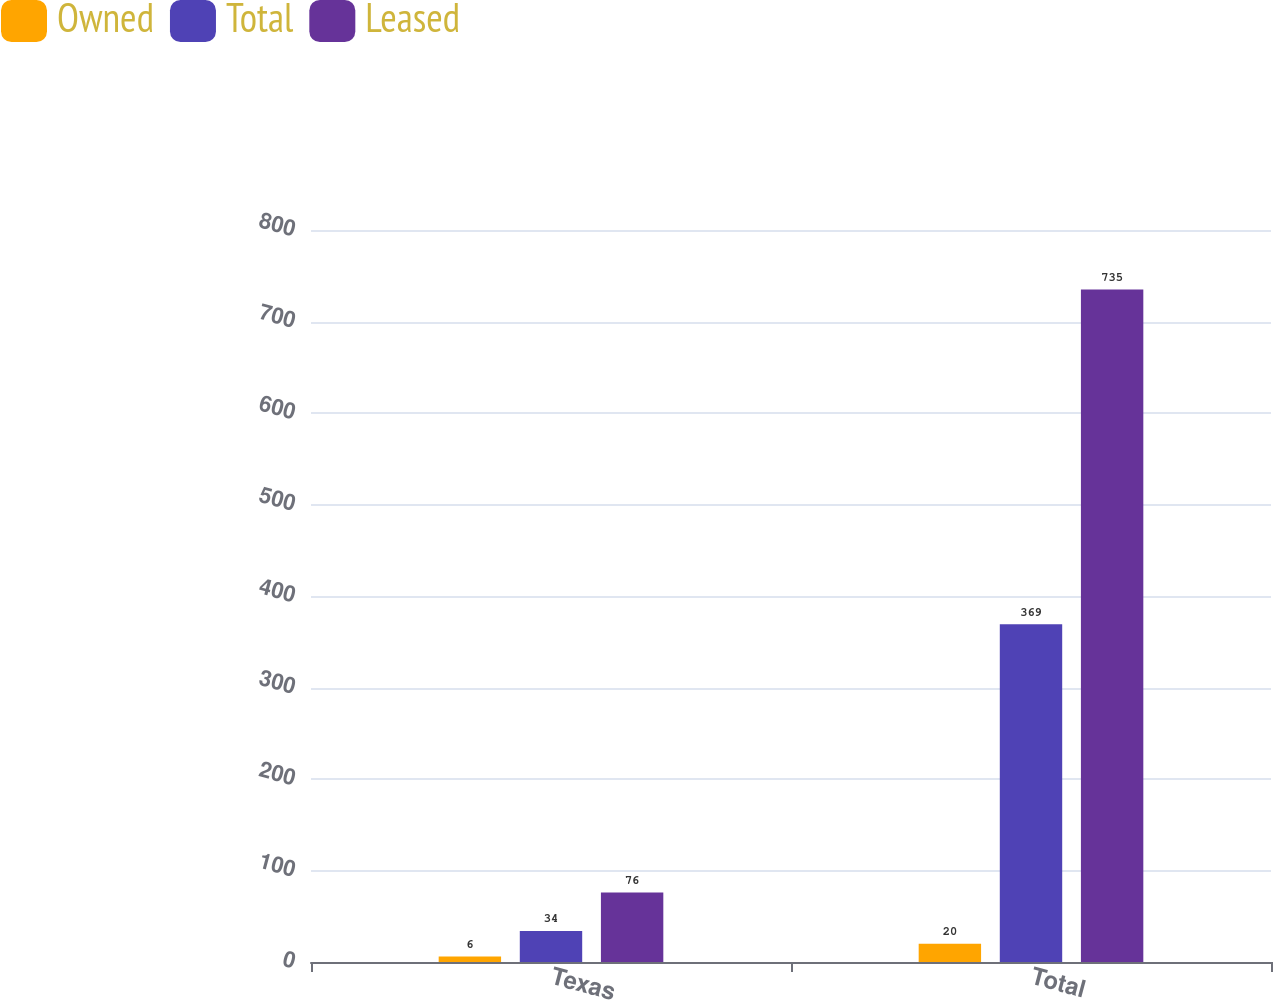<chart> <loc_0><loc_0><loc_500><loc_500><stacked_bar_chart><ecel><fcel>Texas<fcel>Total<nl><fcel>Owned<fcel>6<fcel>20<nl><fcel>Total<fcel>34<fcel>369<nl><fcel>Leased<fcel>76<fcel>735<nl></chart> 